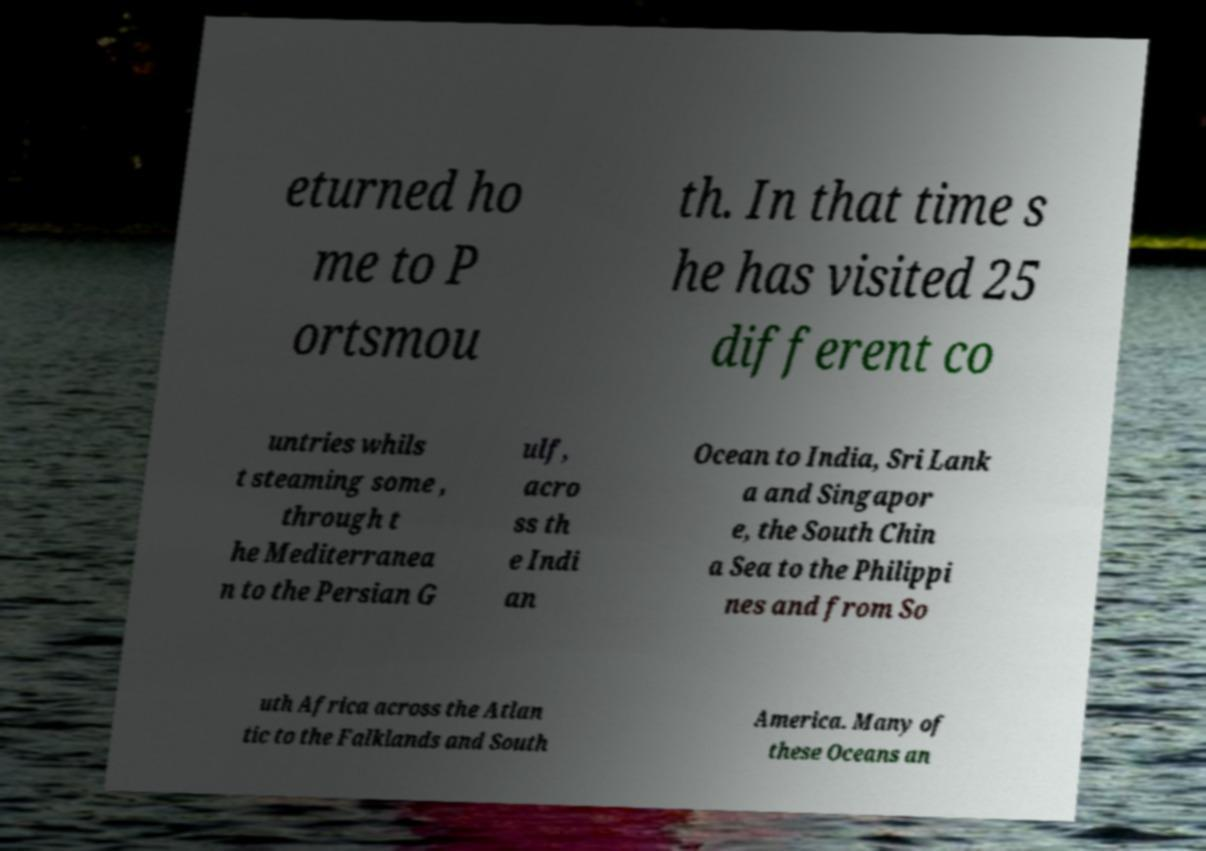Could you extract and type out the text from this image? eturned ho me to P ortsmou th. In that time s he has visited 25 different co untries whils t steaming some , through t he Mediterranea n to the Persian G ulf, acro ss th e Indi an Ocean to India, Sri Lank a and Singapor e, the South Chin a Sea to the Philippi nes and from So uth Africa across the Atlan tic to the Falklands and South America. Many of these Oceans an 